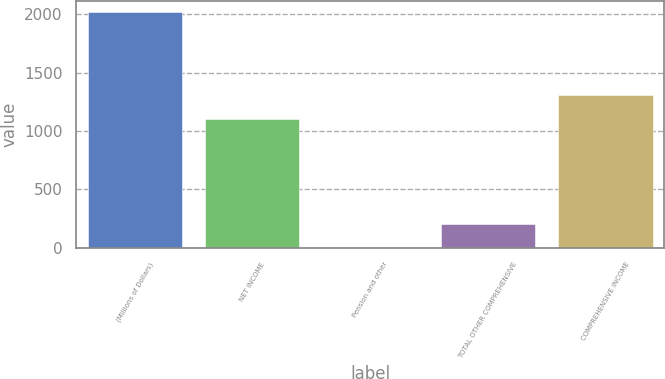Convert chart to OTSL. <chart><loc_0><loc_0><loc_500><loc_500><bar_chart><fcel>(Millions of Dollars)<fcel>NET INCOME<fcel>Pension and other<fcel>TOTAL OTHER COMPREHENSIVE<fcel>COMPREHENSIVE INCOME<nl><fcel>2017<fcel>1104<fcel>1<fcel>202.6<fcel>1305.6<nl></chart> 